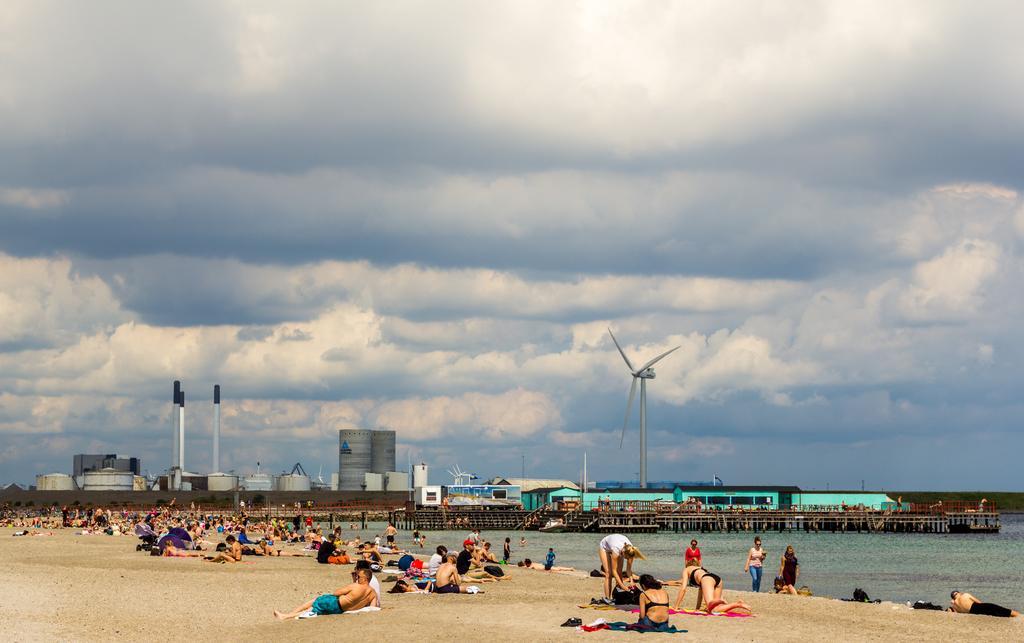Please provide a concise description of this image. In this image I can see at the beach and people relaxing at the beach. I can see a port area, some buildings, tunnels, towers and a windmill. At the top of the image I can see the sky. 